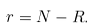Convert formula to latex. <formula><loc_0><loc_0><loc_500><loc_500>r = N - R .</formula> 